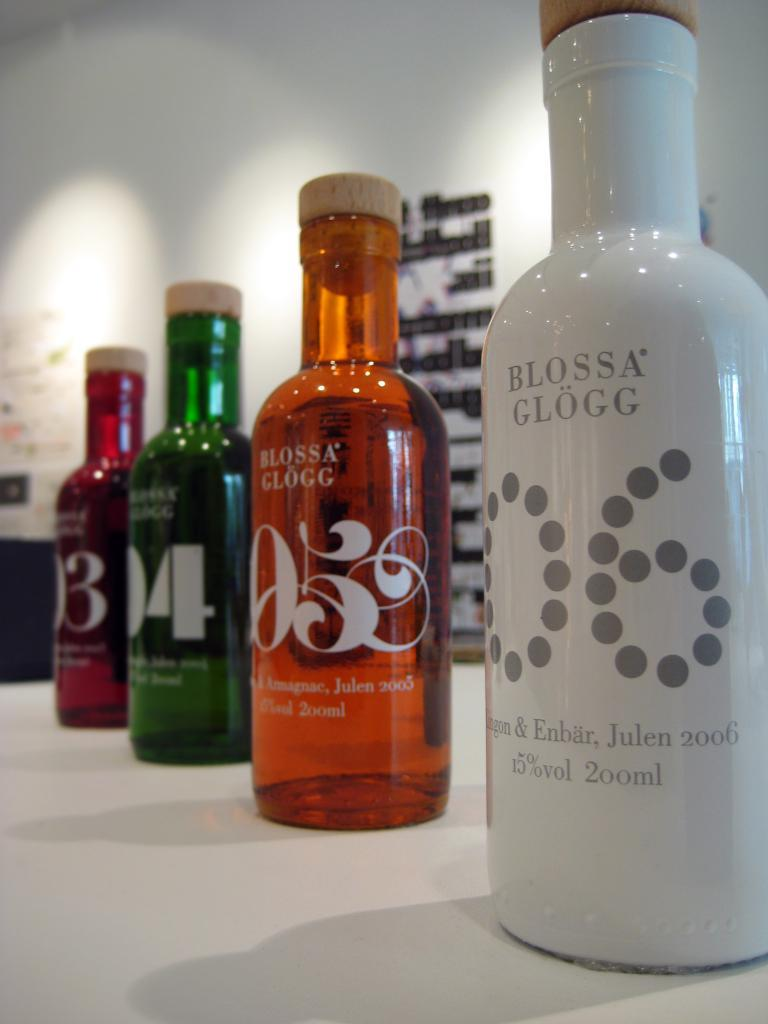<image>
Give a short and clear explanation of the subsequent image. A white bottle of Blossa Glogg 06 is next to other bottles on a table. 